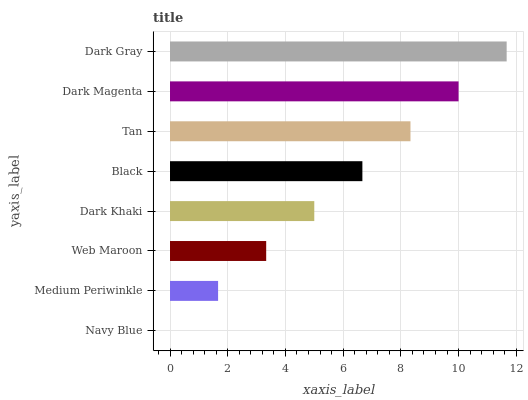Is Navy Blue the minimum?
Answer yes or no. Yes. Is Dark Gray the maximum?
Answer yes or no. Yes. Is Medium Periwinkle the minimum?
Answer yes or no. No. Is Medium Periwinkle the maximum?
Answer yes or no. No. Is Medium Periwinkle greater than Navy Blue?
Answer yes or no. Yes. Is Navy Blue less than Medium Periwinkle?
Answer yes or no. Yes. Is Navy Blue greater than Medium Periwinkle?
Answer yes or no. No. Is Medium Periwinkle less than Navy Blue?
Answer yes or no. No. Is Black the high median?
Answer yes or no. Yes. Is Dark Khaki the low median?
Answer yes or no. Yes. Is Navy Blue the high median?
Answer yes or no. No. Is Medium Periwinkle the low median?
Answer yes or no. No. 